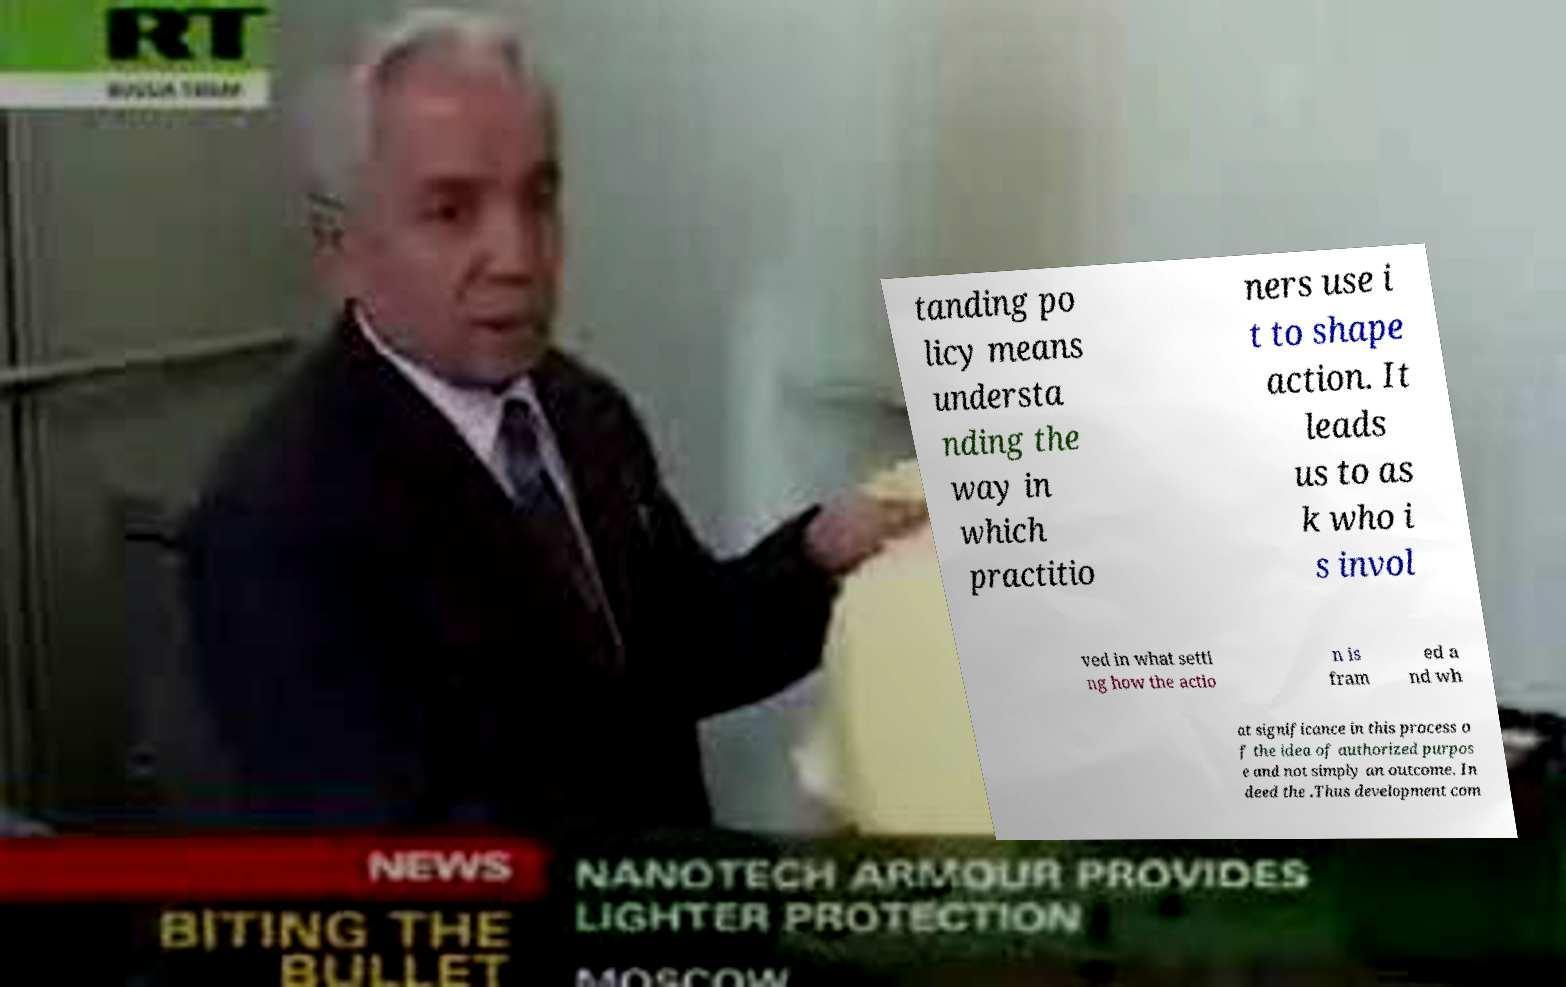Please read and relay the text visible in this image. What does it say? tanding po licy means understa nding the way in which practitio ners use i t to shape action. It leads us to as k who i s invol ved in what setti ng how the actio n is fram ed a nd wh at significance in this process o f the idea of authorized purpos e and not simply an outcome. In deed the .Thus development com 